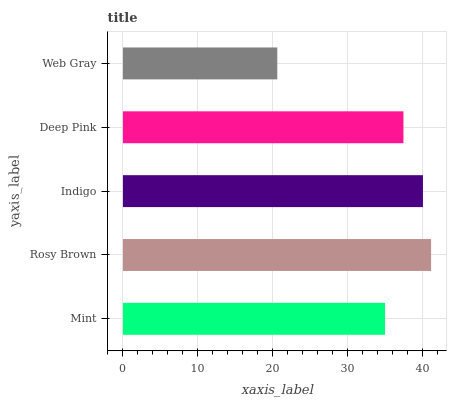Is Web Gray the minimum?
Answer yes or no. Yes. Is Rosy Brown the maximum?
Answer yes or no. Yes. Is Indigo the minimum?
Answer yes or no. No. Is Indigo the maximum?
Answer yes or no. No. Is Rosy Brown greater than Indigo?
Answer yes or no. Yes. Is Indigo less than Rosy Brown?
Answer yes or no. Yes. Is Indigo greater than Rosy Brown?
Answer yes or no. No. Is Rosy Brown less than Indigo?
Answer yes or no. No. Is Deep Pink the high median?
Answer yes or no. Yes. Is Deep Pink the low median?
Answer yes or no. Yes. Is Web Gray the high median?
Answer yes or no. No. Is Mint the low median?
Answer yes or no. No. 